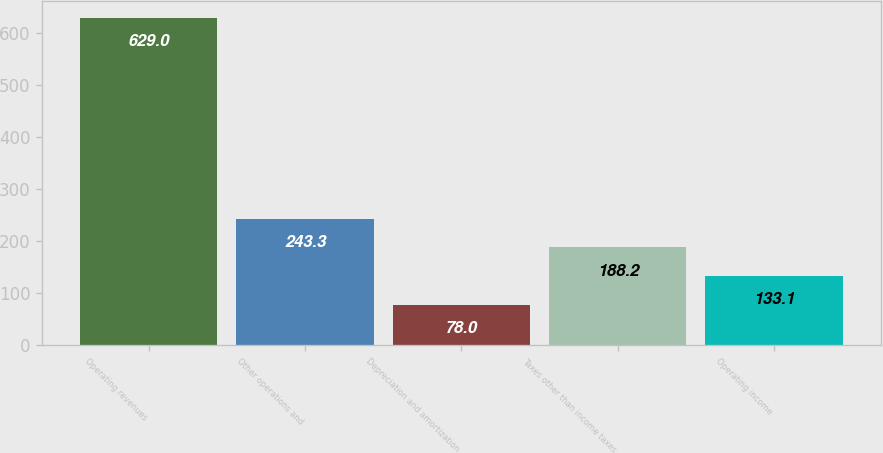Convert chart to OTSL. <chart><loc_0><loc_0><loc_500><loc_500><bar_chart><fcel>Operating revenues<fcel>Other operations and<fcel>Depreciation and amortization<fcel>Taxes other than income taxes<fcel>Operating income<nl><fcel>629<fcel>243.3<fcel>78<fcel>188.2<fcel>133.1<nl></chart> 